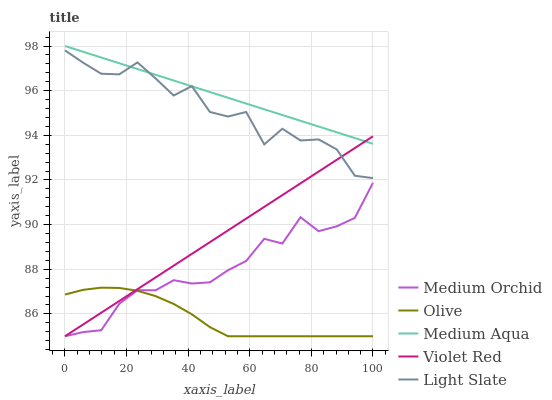Does Light Slate have the minimum area under the curve?
Answer yes or no. No. Does Light Slate have the maximum area under the curve?
Answer yes or no. No. Is Violet Red the smoothest?
Answer yes or no. No. Is Violet Red the roughest?
Answer yes or no. No. Does Light Slate have the lowest value?
Answer yes or no. No. Does Light Slate have the highest value?
Answer yes or no. No. Is Olive less than Medium Aqua?
Answer yes or no. Yes. Is Light Slate greater than Medium Orchid?
Answer yes or no. Yes. Does Olive intersect Medium Aqua?
Answer yes or no. No. 